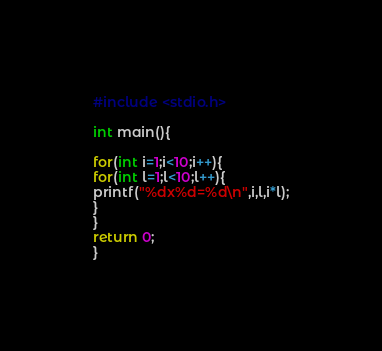<code> <loc_0><loc_0><loc_500><loc_500><_C_>#include <stdio.h>

int main(){

for(int i=1;i<10;i++){
for(int l=1;l<10;l++){
printf("%dx%d=%d\n",i,l,i*l);
}
}
return 0;
}</code> 